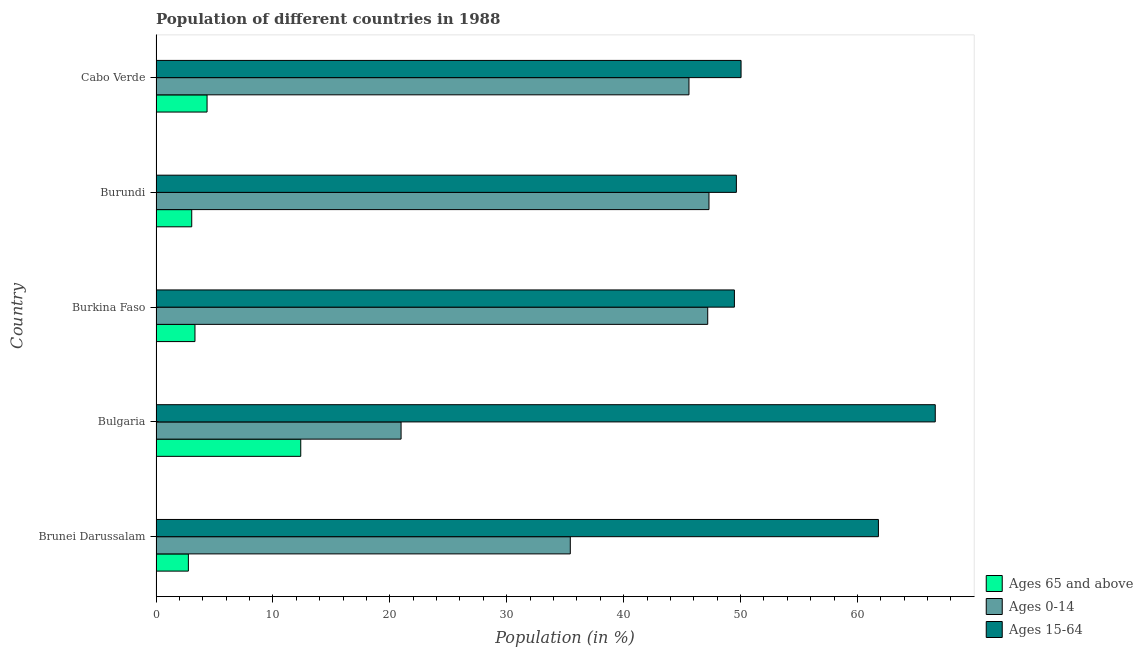How many different coloured bars are there?
Your answer should be very brief. 3. How many groups of bars are there?
Ensure brevity in your answer.  5. How many bars are there on the 1st tick from the top?
Your answer should be compact. 3. What is the label of the 5th group of bars from the top?
Offer a terse response. Brunei Darussalam. In how many cases, is the number of bars for a given country not equal to the number of legend labels?
Ensure brevity in your answer.  0. What is the percentage of population within the age-group 0-14 in Brunei Darussalam?
Provide a short and direct response. 35.44. Across all countries, what is the maximum percentage of population within the age-group 0-14?
Offer a terse response. 47.3. Across all countries, what is the minimum percentage of population within the age-group 15-64?
Provide a short and direct response. 49.48. In which country was the percentage of population within the age-group 0-14 maximum?
Provide a short and direct response. Burundi. In which country was the percentage of population within the age-group 15-64 minimum?
Give a very brief answer. Burkina Faso. What is the total percentage of population within the age-group 15-64 in the graph?
Your answer should be very brief. 277.62. What is the difference between the percentage of population within the age-group of 65 and above in Burundi and that in Cabo Verde?
Provide a short and direct response. -1.31. What is the difference between the percentage of population within the age-group 0-14 in Burkina Faso and the percentage of population within the age-group 15-64 in Cabo Verde?
Your response must be concise. -2.85. What is the average percentage of population within the age-group 0-14 per country?
Your answer should be compact. 39.3. What is the difference between the percentage of population within the age-group 0-14 and percentage of population within the age-group of 65 and above in Cabo Verde?
Ensure brevity in your answer.  41.22. In how many countries, is the percentage of population within the age-group of 65 and above greater than 64 %?
Make the answer very short. 0. What is the ratio of the percentage of population within the age-group of 65 and above in Bulgaria to that in Burkina Faso?
Offer a very short reply. 3.72. What is the difference between the highest and the second highest percentage of population within the age-group of 65 and above?
Your answer should be compact. 8.01. What is the difference between the highest and the lowest percentage of population within the age-group 0-14?
Make the answer very short. 26.34. Is the sum of the percentage of population within the age-group 0-14 in Brunei Darussalam and Burundi greater than the maximum percentage of population within the age-group of 65 and above across all countries?
Give a very brief answer. Yes. What does the 2nd bar from the top in Cabo Verde represents?
Keep it short and to the point. Ages 0-14. What does the 1st bar from the bottom in Brunei Darussalam represents?
Make the answer very short. Ages 65 and above. Is it the case that in every country, the sum of the percentage of population within the age-group of 65 and above and percentage of population within the age-group 0-14 is greater than the percentage of population within the age-group 15-64?
Your answer should be compact. No. How many bars are there?
Provide a succinct answer. 15. How many countries are there in the graph?
Your answer should be compact. 5. Where does the legend appear in the graph?
Your answer should be very brief. Bottom right. What is the title of the graph?
Offer a very short reply. Population of different countries in 1988. What is the label or title of the X-axis?
Your answer should be compact. Population (in %). What is the label or title of the Y-axis?
Your response must be concise. Country. What is the Population (in %) in Ages 65 and above in Brunei Darussalam?
Offer a terse response. 2.77. What is the Population (in %) in Ages 0-14 in Brunei Darussalam?
Your answer should be very brief. 35.44. What is the Population (in %) of Ages 15-64 in Brunei Darussalam?
Your answer should be compact. 61.79. What is the Population (in %) in Ages 65 and above in Bulgaria?
Provide a succinct answer. 12.38. What is the Population (in %) in Ages 0-14 in Bulgaria?
Your response must be concise. 20.96. What is the Population (in %) in Ages 15-64 in Bulgaria?
Ensure brevity in your answer.  66.66. What is the Population (in %) of Ages 65 and above in Burkina Faso?
Keep it short and to the point. 3.33. What is the Population (in %) in Ages 0-14 in Burkina Faso?
Give a very brief answer. 47.19. What is the Population (in %) in Ages 15-64 in Burkina Faso?
Your answer should be compact. 49.48. What is the Population (in %) of Ages 65 and above in Burundi?
Ensure brevity in your answer.  3.06. What is the Population (in %) of Ages 0-14 in Burundi?
Offer a very short reply. 47.3. What is the Population (in %) in Ages 15-64 in Burundi?
Give a very brief answer. 49.64. What is the Population (in %) in Ages 65 and above in Cabo Verde?
Give a very brief answer. 4.37. What is the Population (in %) in Ages 0-14 in Cabo Verde?
Keep it short and to the point. 45.59. What is the Population (in %) of Ages 15-64 in Cabo Verde?
Your response must be concise. 50.04. Across all countries, what is the maximum Population (in %) of Ages 65 and above?
Your response must be concise. 12.38. Across all countries, what is the maximum Population (in %) of Ages 0-14?
Offer a very short reply. 47.3. Across all countries, what is the maximum Population (in %) in Ages 15-64?
Your response must be concise. 66.66. Across all countries, what is the minimum Population (in %) in Ages 65 and above?
Give a very brief answer. 2.77. Across all countries, what is the minimum Population (in %) in Ages 0-14?
Give a very brief answer. 20.96. Across all countries, what is the minimum Population (in %) of Ages 15-64?
Your answer should be very brief. 49.48. What is the total Population (in %) of Ages 65 and above in the graph?
Offer a very short reply. 25.9. What is the total Population (in %) in Ages 0-14 in the graph?
Provide a succinct answer. 196.48. What is the total Population (in %) in Ages 15-64 in the graph?
Give a very brief answer. 277.62. What is the difference between the Population (in %) of Ages 65 and above in Brunei Darussalam and that in Bulgaria?
Provide a succinct answer. -9.61. What is the difference between the Population (in %) in Ages 0-14 in Brunei Darussalam and that in Bulgaria?
Offer a very short reply. 14.47. What is the difference between the Population (in %) in Ages 15-64 in Brunei Darussalam and that in Bulgaria?
Provide a short and direct response. -4.86. What is the difference between the Population (in %) of Ages 65 and above in Brunei Darussalam and that in Burkina Faso?
Offer a terse response. -0.56. What is the difference between the Population (in %) of Ages 0-14 in Brunei Darussalam and that in Burkina Faso?
Give a very brief answer. -11.76. What is the difference between the Population (in %) in Ages 15-64 in Brunei Darussalam and that in Burkina Faso?
Make the answer very short. 12.32. What is the difference between the Population (in %) in Ages 65 and above in Brunei Darussalam and that in Burundi?
Provide a succinct answer. -0.29. What is the difference between the Population (in %) in Ages 0-14 in Brunei Darussalam and that in Burundi?
Make the answer very short. -11.86. What is the difference between the Population (in %) of Ages 15-64 in Brunei Darussalam and that in Burundi?
Offer a terse response. 12.15. What is the difference between the Population (in %) in Ages 65 and above in Brunei Darussalam and that in Cabo Verde?
Provide a short and direct response. -1.6. What is the difference between the Population (in %) in Ages 0-14 in Brunei Darussalam and that in Cabo Verde?
Make the answer very short. -10.15. What is the difference between the Population (in %) of Ages 15-64 in Brunei Darussalam and that in Cabo Verde?
Offer a very short reply. 11.75. What is the difference between the Population (in %) in Ages 65 and above in Bulgaria and that in Burkina Faso?
Your answer should be compact. 9.05. What is the difference between the Population (in %) of Ages 0-14 in Bulgaria and that in Burkina Faso?
Ensure brevity in your answer.  -26.23. What is the difference between the Population (in %) in Ages 15-64 in Bulgaria and that in Burkina Faso?
Keep it short and to the point. 17.18. What is the difference between the Population (in %) of Ages 65 and above in Bulgaria and that in Burundi?
Offer a very short reply. 9.33. What is the difference between the Population (in %) in Ages 0-14 in Bulgaria and that in Burundi?
Keep it short and to the point. -26.34. What is the difference between the Population (in %) in Ages 15-64 in Bulgaria and that in Burundi?
Your answer should be compact. 17.01. What is the difference between the Population (in %) in Ages 65 and above in Bulgaria and that in Cabo Verde?
Keep it short and to the point. 8.01. What is the difference between the Population (in %) of Ages 0-14 in Bulgaria and that in Cabo Verde?
Your response must be concise. -24.63. What is the difference between the Population (in %) in Ages 15-64 in Bulgaria and that in Cabo Verde?
Offer a very short reply. 16.61. What is the difference between the Population (in %) of Ages 65 and above in Burkina Faso and that in Burundi?
Ensure brevity in your answer.  0.28. What is the difference between the Population (in %) in Ages 0-14 in Burkina Faso and that in Burundi?
Keep it short and to the point. -0.11. What is the difference between the Population (in %) in Ages 15-64 in Burkina Faso and that in Burundi?
Your answer should be very brief. -0.17. What is the difference between the Population (in %) of Ages 65 and above in Burkina Faso and that in Cabo Verde?
Give a very brief answer. -1.04. What is the difference between the Population (in %) of Ages 0-14 in Burkina Faso and that in Cabo Verde?
Provide a short and direct response. 1.6. What is the difference between the Population (in %) in Ages 15-64 in Burkina Faso and that in Cabo Verde?
Provide a short and direct response. -0.57. What is the difference between the Population (in %) in Ages 65 and above in Burundi and that in Cabo Verde?
Keep it short and to the point. -1.31. What is the difference between the Population (in %) in Ages 0-14 in Burundi and that in Cabo Verde?
Offer a terse response. 1.71. What is the difference between the Population (in %) in Ages 15-64 in Burundi and that in Cabo Verde?
Provide a succinct answer. -0.4. What is the difference between the Population (in %) of Ages 65 and above in Brunei Darussalam and the Population (in %) of Ages 0-14 in Bulgaria?
Provide a short and direct response. -18.2. What is the difference between the Population (in %) in Ages 65 and above in Brunei Darussalam and the Population (in %) in Ages 15-64 in Bulgaria?
Keep it short and to the point. -63.89. What is the difference between the Population (in %) of Ages 0-14 in Brunei Darussalam and the Population (in %) of Ages 15-64 in Bulgaria?
Provide a short and direct response. -31.22. What is the difference between the Population (in %) in Ages 65 and above in Brunei Darussalam and the Population (in %) in Ages 0-14 in Burkina Faso?
Keep it short and to the point. -44.42. What is the difference between the Population (in %) in Ages 65 and above in Brunei Darussalam and the Population (in %) in Ages 15-64 in Burkina Faso?
Make the answer very short. -46.71. What is the difference between the Population (in %) in Ages 0-14 in Brunei Darussalam and the Population (in %) in Ages 15-64 in Burkina Faso?
Provide a succinct answer. -14.04. What is the difference between the Population (in %) in Ages 65 and above in Brunei Darussalam and the Population (in %) in Ages 0-14 in Burundi?
Your answer should be very brief. -44.53. What is the difference between the Population (in %) of Ages 65 and above in Brunei Darussalam and the Population (in %) of Ages 15-64 in Burundi?
Your answer should be very brief. -46.88. What is the difference between the Population (in %) of Ages 0-14 in Brunei Darussalam and the Population (in %) of Ages 15-64 in Burundi?
Give a very brief answer. -14.21. What is the difference between the Population (in %) in Ages 65 and above in Brunei Darussalam and the Population (in %) in Ages 0-14 in Cabo Verde?
Keep it short and to the point. -42.82. What is the difference between the Population (in %) of Ages 65 and above in Brunei Darussalam and the Population (in %) of Ages 15-64 in Cabo Verde?
Offer a very short reply. -47.28. What is the difference between the Population (in %) in Ages 0-14 in Brunei Darussalam and the Population (in %) in Ages 15-64 in Cabo Verde?
Ensure brevity in your answer.  -14.61. What is the difference between the Population (in %) in Ages 65 and above in Bulgaria and the Population (in %) in Ages 0-14 in Burkina Faso?
Offer a very short reply. -34.81. What is the difference between the Population (in %) of Ages 65 and above in Bulgaria and the Population (in %) of Ages 15-64 in Burkina Faso?
Provide a short and direct response. -37.1. What is the difference between the Population (in %) of Ages 0-14 in Bulgaria and the Population (in %) of Ages 15-64 in Burkina Faso?
Offer a terse response. -28.51. What is the difference between the Population (in %) of Ages 65 and above in Bulgaria and the Population (in %) of Ages 0-14 in Burundi?
Your answer should be very brief. -34.92. What is the difference between the Population (in %) in Ages 65 and above in Bulgaria and the Population (in %) in Ages 15-64 in Burundi?
Your response must be concise. -37.26. What is the difference between the Population (in %) in Ages 0-14 in Bulgaria and the Population (in %) in Ages 15-64 in Burundi?
Give a very brief answer. -28.68. What is the difference between the Population (in %) of Ages 65 and above in Bulgaria and the Population (in %) of Ages 0-14 in Cabo Verde?
Keep it short and to the point. -33.21. What is the difference between the Population (in %) in Ages 65 and above in Bulgaria and the Population (in %) in Ages 15-64 in Cabo Verde?
Offer a very short reply. -37.66. What is the difference between the Population (in %) in Ages 0-14 in Bulgaria and the Population (in %) in Ages 15-64 in Cabo Verde?
Give a very brief answer. -29.08. What is the difference between the Population (in %) in Ages 65 and above in Burkina Faso and the Population (in %) in Ages 0-14 in Burundi?
Make the answer very short. -43.97. What is the difference between the Population (in %) in Ages 65 and above in Burkina Faso and the Population (in %) in Ages 15-64 in Burundi?
Ensure brevity in your answer.  -46.31. What is the difference between the Population (in %) of Ages 0-14 in Burkina Faso and the Population (in %) of Ages 15-64 in Burundi?
Provide a short and direct response. -2.45. What is the difference between the Population (in %) of Ages 65 and above in Burkina Faso and the Population (in %) of Ages 0-14 in Cabo Verde?
Your response must be concise. -42.26. What is the difference between the Population (in %) in Ages 65 and above in Burkina Faso and the Population (in %) in Ages 15-64 in Cabo Verde?
Offer a very short reply. -46.71. What is the difference between the Population (in %) of Ages 0-14 in Burkina Faso and the Population (in %) of Ages 15-64 in Cabo Verde?
Offer a terse response. -2.85. What is the difference between the Population (in %) in Ages 65 and above in Burundi and the Population (in %) in Ages 0-14 in Cabo Verde?
Make the answer very short. -42.53. What is the difference between the Population (in %) in Ages 65 and above in Burundi and the Population (in %) in Ages 15-64 in Cabo Verde?
Your answer should be very brief. -46.99. What is the difference between the Population (in %) in Ages 0-14 in Burundi and the Population (in %) in Ages 15-64 in Cabo Verde?
Offer a terse response. -2.74. What is the average Population (in %) in Ages 65 and above per country?
Make the answer very short. 5.18. What is the average Population (in %) of Ages 0-14 per country?
Provide a short and direct response. 39.3. What is the average Population (in %) in Ages 15-64 per country?
Ensure brevity in your answer.  55.52. What is the difference between the Population (in %) in Ages 65 and above and Population (in %) in Ages 0-14 in Brunei Darussalam?
Your answer should be very brief. -32.67. What is the difference between the Population (in %) in Ages 65 and above and Population (in %) in Ages 15-64 in Brunei Darussalam?
Make the answer very short. -59.03. What is the difference between the Population (in %) in Ages 0-14 and Population (in %) in Ages 15-64 in Brunei Darussalam?
Give a very brief answer. -26.36. What is the difference between the Population (in %) of Ages 65 and above and Population (in %) of Ages 0-14 in Bulgaria?
Offer a terse response. -8.58. What is the difference between the Population (in %) of Ages 65 and above and Population (in %) of Ages 15-64 in Bulgaria?
Provide a succinct answer. -54.28. What is the difference between the Population (in %) of Ages 0-14 and Population (in %) of Ages 15-64 in Bulgaria?
Ensure brevity in your answer.  -45.69. What is the difference between the Population (in %) of Ages 65 and above and Population (in %) of Ages 0-14 in Burkina Faso?
Provide a short and direct response. -43.86. What is the difference between the Population (in %) of Ages 65 and above and Population (in %) of Ages 15-64 in Burkina Faso?
Make the answer very short. -46.14. What is the difference between the Population (in %) in Ages 0-14 and Population (in %) in Ages 15-64 in Burkina Faso?
Your answer should be very brief. -2.28. What is the difference between the Population (in %) of Ages 65 and above and Population (in %) of Ages 0-14 in Burundi?
Your answer should be compact. -44.25. What is the difference between the Population (in %) in Ages 65 and above and Population (in %) in Ages 15-64 in Burundi?
Offer a terse response. -46.59. What is the difference between the Population (in %) of Ages 0-14 and Population (in %) of Ages 15-64 in Burundi?
Give a very brief answer. -2.34. What is the difference between the Population (in %) in Ages 65 and above and Population (in %) in Ages 0-14 in Cabo Verde?
Your answer should be compact. -41.22. What is the difference between the Population (in %) of Ages 65 and above and Population (in %) of Ages 15-64 in Cabo Verde?
Your answer should be very brief. -45.68. What is the difference between the Population (in %) in Ages 0-14 and Population (in %) in Ages 15-64 in Cabo Verde?
Your response must be concise. -4.46. What is the ratio of the Population (in %) in Ages 65 and above in Brunei Darussalam to that in Bulgaria?
Provide a short and direct response. 0.22. What is the ratio of the Population (in %) in Ages 0-14 in Brunei Darussalam to that in Bulgaria?
Keep it short and to the point. 1.69. What is the ratio of the Population (in %) of Ages 15-64 in Brunei Darussalam to that in Bulgaria?
Make the answer very short. 0.93. What is the ratio of the Population (in %) of Ages 65 and above in Brunei Darussalam to that in Burkina Faso?
Give a very brief answer. 0.83. What is the ratio of the Population (in %) of Ages 0-14 in Brunei Darussalam to that in Burkina Faso?
Offer a very short reply. 0.75. What is the ratio of the Population (in %) in Ages 15-64 in Brunei Darussalam to that in Burkina Faso?
Give a very brief answer. 1.25. What is the ratio of the Population (in %) in Ages 65 and above in Brunei Darussalam to that in Burundi?
Your answer should be compact. 0.91. What is the ratio of the Population (in %) of Ages 0-14 in Brunei Darussalam to that in Burundi?
Provide a short and direct response. 0.75. What is the ratio of the Population (in %) in Ages 15-64 in Brunei Darussalam to that in Burundi?
Make the answer very short. 1.24. What is the ratio of the Population (in %) in Ages 65 and above in Brunei Darussalam to that in Cabo Verde?
Your response must be concise. 0.63. What is the ratio of the Population (in %) of Ages 0-14 in Brunei Darussalam to that in Cabo Verde?
Your answer should be compact. 0.78. What is the ratio of the Population (in %) in Ages 15-64 in Brunei Darussalam to that in Cabo Verde?
Give a very brief answer. 1.23. What is the ratio of the Population (in %) in Ages 65 and above in Bulgaria to that in Burkina Faso?
Give a very brief answer. 3.72. What is the ratio of the Population (in %) of Ages 0-14 in Bulgaria to that in Burkina Faso?
Your answer should be very brief. 0.44. What is the ratio of the Population (in %) of Ages 15-64 in Bulgaria to that in Burkina Faso?
Your response must be concise. 1.35. What is the ratio of the Population (in %) in Ages 65 and above in Bulgaria to that in Burundi?
Ensure brevity in your answer.  4.05. What is the ratio of the Population (in %) in Ages 0-14 in Bulgaria to that in Burundi?
Offer a very short reply. 0.44. What is the ratio of the Population (in %) of Ages 15-64 in Bulgaria to that in Burundi?
Offer a very short reply. 1.34. What is the ratio of the Population (in %) in Ages 65 and above in Bulgaria to that in Cabo Verde?
Offer a very short reply. 2.84. What is the ratio of the Population (in %) of Ages 0-14 in Bulgaria to that in Cabo Verde?
Provide a short and direct response. 0.46. What is the ratio of the Population (in %) of Ages 15-64 in Bulgaria to that in Cabo Verde?
Keep it short and to the point. 1.33. What is the ratio of the Population (in %) of Ages 65 and above in Burkina Faso to that in Burundi?
Your response must be concise. 1.09. What is the ratio of the Population (in %) of Ages 0-14 in Burkina Faso to that in Burundi?
Your answer should be compact. 1. What is the ratio of the Population (in %) in Ages 65 and above in Burkina Faso to that in Cabo Verde?
Offer a very short reply. 0.76. What is the ratio of the Population (in %) of Ages 0-14 in Burkina Faso to that in Cabo Verde?
Ensure brevity in your answer.  1.04. What is the ratio of the Population (in %) in Ages 65 and above in Burundi to that in Cabo Verde?
Make the answer very short. 0.7. What is the ratio of the Population (in %) of Ages 0-14 in Burundi to that in Cabo Verde?
Your answer should be compact. 1.04. What is the difference between the highest and the second highest Population (in %) of Ages 65 and above?
Give a very brief answer. 8.01. What is the difference between the highest and the second highest Population (in %) in Ages 0-14?
Ensure brevity in your answer.  0.11. What is the difference between the highest and the second highest Population (in %) of Ages 15-64?
Make the answer very short. 4.86. What is the difference between the highest and the lowest Population (in %) in Ages 65 and above?
Your answer should be compact. 9.61. What is the difference between the highest and the lowest Population (in %) of Ages 0-14?
Give a very brief answer. 26.34. What is the difference between the highest and the lowest Population (in %) in Ages 15-64?
Provide a short and direct response. 17.18. 